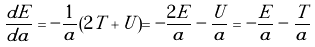<formula> <loc_0><loc_0><loc_500><loc_500>\frac { d E } { d a } = - \frac { 1 } { a } ( 2 T + U ) = - \frac { 2 E } { a } - \frac { U } { a } = - \frac { E } { a } - \frac { T } { a }</formula> 